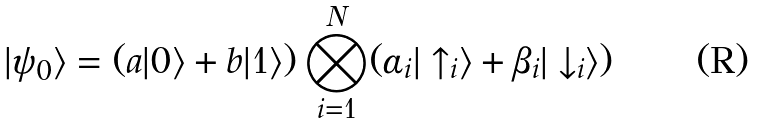<formula> <loc_0><loc_0><loc_500><loc_500>| \psi _ { 0 } \rangle = ( a | 0 \rangle + b | 1 \rangle ) \bigotimes _ { i = 1 } ^ { N } ( \alpha _ { i } | \uparrow _ { i } \rangle + \beta _ { i } | \downarrow _ { i } \rangle )</formula> 